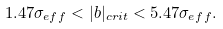Convert formula to latex. <formula><loc_0><loc_0><loc_500><loc_500>1 . 4 7 \sigma _ { e f f } < | b | _ { c r i t } < 5 . 4 7 \sigma _ { e f f } .</formula> 